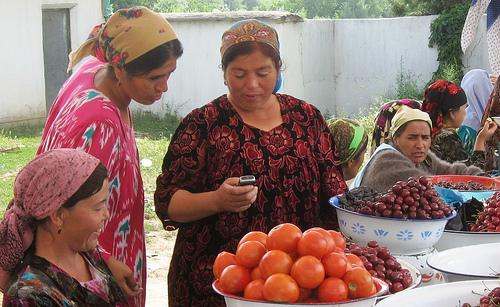The largest food item on any of these tables is found in what sauce? tomato 